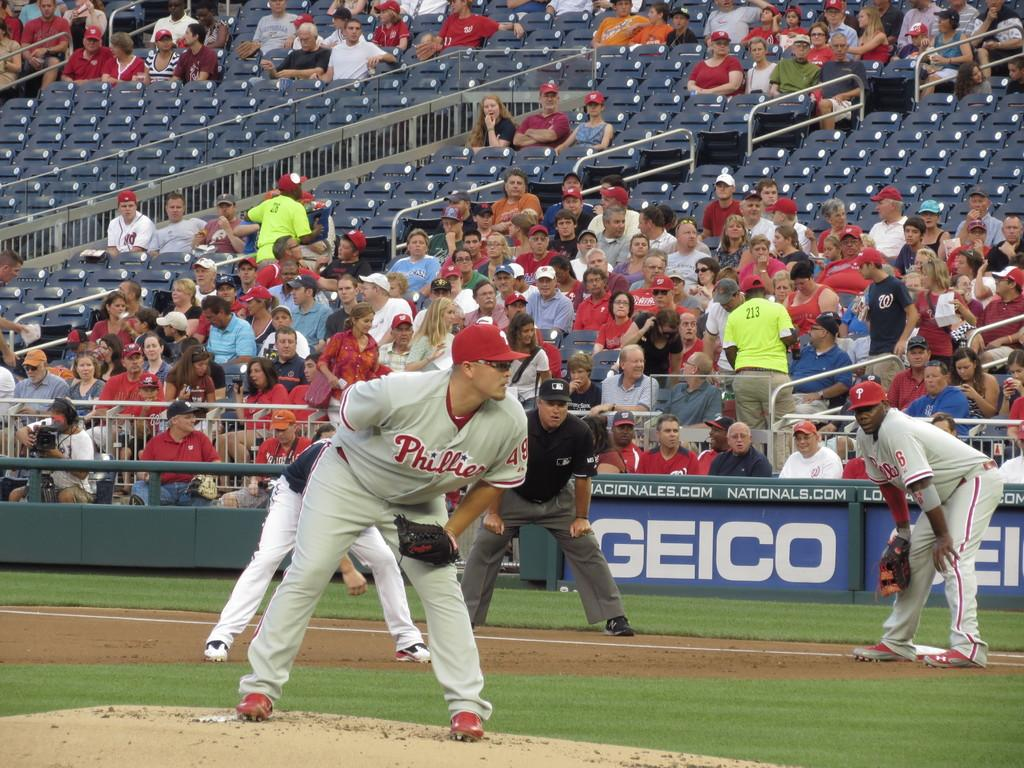<image>
Summarize the visual content of the image. A pitcher for the Phillies is standing at the pitcher's mound, leaning in, getting ready to throw the ball. 